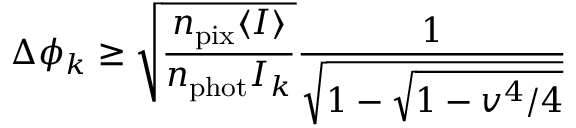<formula> <loc_0><loc_0><loc_500><loc_500>\Delta \phi _ { k } \geq \sqrt { \frac { n _ { p i x } \langle I \rangle } { n _ { p h o t } I _ { k } } } \frac { 1 } { \sqrt { 1 - \sqrt { 1 - v ^ { 4 } / 4 } } }</formula> 